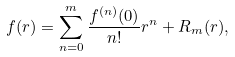<formula> <loc_0><loc_0><loc_500><loc_500>f ( r ) = \sum _ { n = 0 } ^ { m } \frac { f ^ { ( n ) } ( 0 ) } { n ! } r ^ { n } + R _ { m } ( r ) ,</formula> 